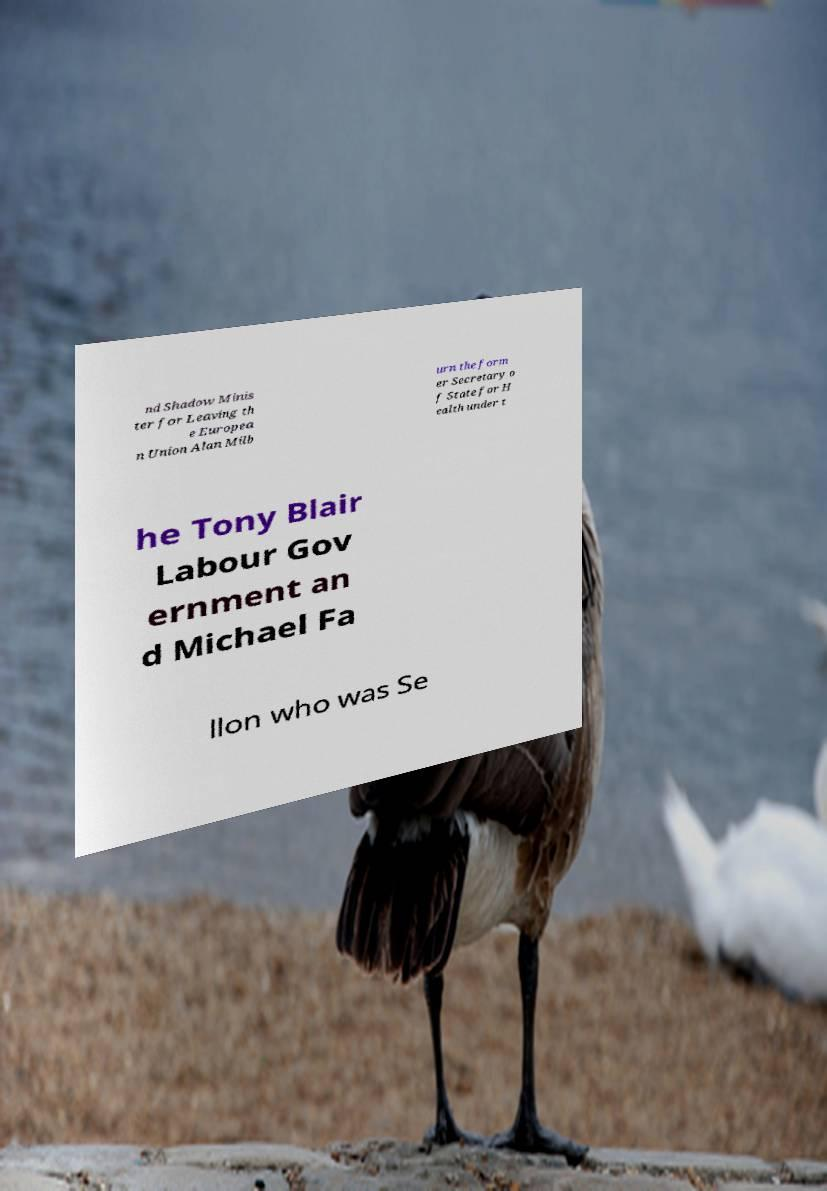Could you assist in decoding the text presented in this image and type it out clearly? nd Shadow Minis ter for Leaving th e Europea n Union Alan Milb urn the form er Secretary o f State for H ealth under t he Tony Blair Labour Gov ernment an d Michael Fa llon who was Se 